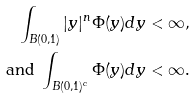<formula> <loc_0><loc_0><loc_500><loc_500>\int _ { B ( 0 , 1 ) } | y | ^ { n } \Phi ( y ) d y < \infty , \\ \text { and } \int _ { B ( 0 , 1 ) ^ { c } } \Phi ( y ) d y < \infty .</formula> 